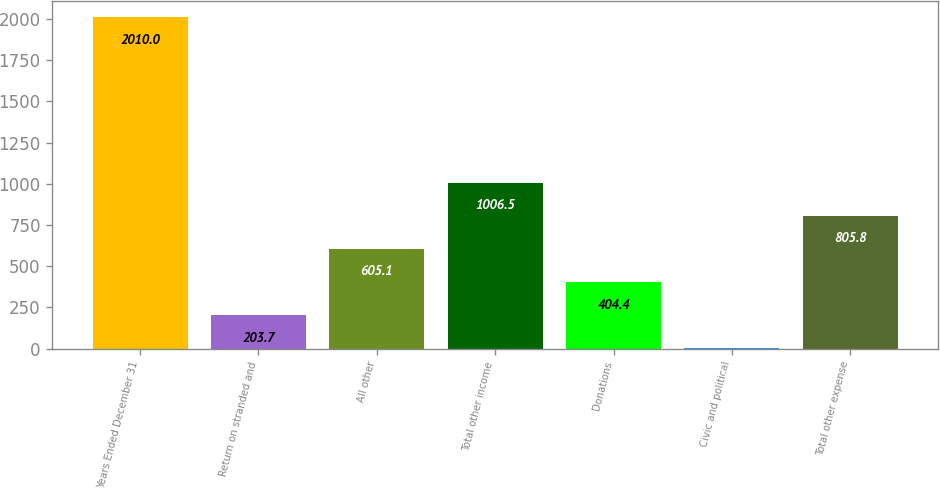<chart> <loc_0><loc_0><loc_500><loc_500><bar_chart><fcel>Years Ended December 31<fcel>Return on stranded and<fcel>All other<fcel>Total other income<fcel>Donations<fcel>Civic and political<fcel>Total other expense<nl><fcel>2010<fcel>203.7<fcel>605.1<fcel>1006.5<fcel>404.4<fcel>3<fcel>805.8<nl></chart> 